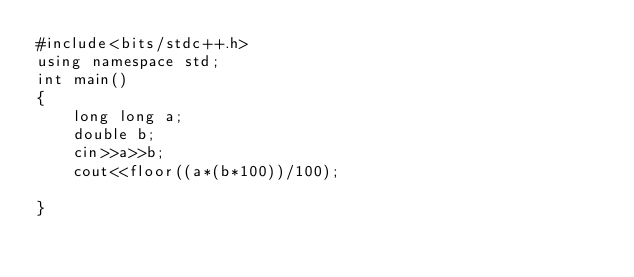Convert code to text. <code><loc_0><loc_0><loc_500><loc_500><_C++_>#include<bits/stdc++.h>
using namespace std;
int main()
{
    long long a;
    double b;
    cin>>a>>b;
    cout<<floor((a*(b*100))/100);

}




</code> 